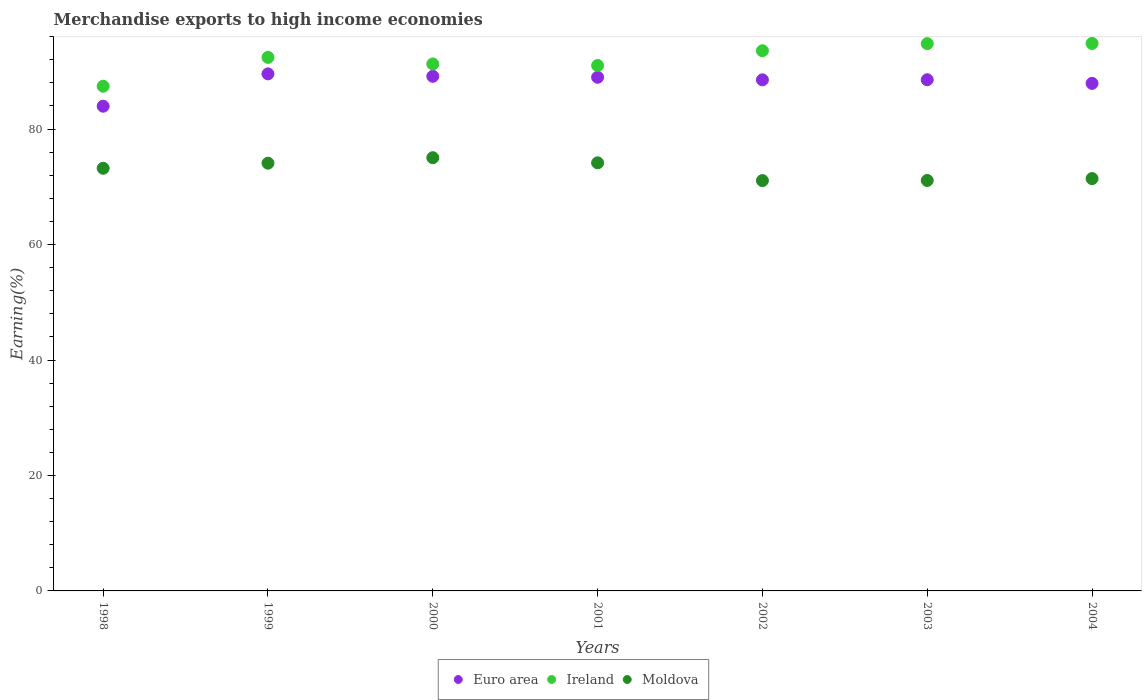How many different coloured dotlines are there?
Offer a terse response. 3. What is the percentage of amount earned from merchandise exports in Euro area in 1998?
Keep it short and to the point. 83.96. Across all years, what is the maximum percentage of amount earned from merchandise exports in Moldova?
Provide a short and direct response. 75.04. Across all years, what is the minimum percentage of amount earned from merchandise exports in Moldova?
Make the answer very short. 71.07. In which year was the percentage of amount earned from merchandise exports in Moldova maximum?
Provide a succinct answer. 2000. In which year was the percentage of amount earned from merchandise exports in Euro area minimum?
Your response must be concise. 1998. What is the total percentage of amount earned from merchandise exports in Ireland in the graph?
Your answer should be compact. 645.35. What is the difference between the percentage of amount earned from merchandise exports in Ireland in 2000 and that in 2002?
Your response must be concise. -2.29. What is the difference between the percentage of amount earned from merchandise exports in Euro area in 2003 and the percentage of amount earned from merchandise exports in Ireland in 2001?
Offer a very short reply. -2.47. What is the average percentage of amount earned from merchandise exports in Euro area per year?
Give a very brief answer. 88.09. In the year 2001, what is the difference between the percentage of amount earned from merchandise exports in Moldova and percentage of amount earned from merchandise exports in Ireland?
Keep it short and to the point. -16.86. In how many years, is the percentage of amount earned from merchandise exports in Moldova greater than 92 %?
Offer a very short reply. 0. What is the ratio of the percentage of amount earned from merchandise exports in Euro area in 2001 to that in 2002?
Offer a terse response. 1.01. Is the percentage of amount earned from merchandise exports in Ireland in 2000 less than that in 2004?
Give a very brief answer. Yes. What is the difference between the highest and the second highest percentage of amount earned from merchandise exports in Ireland?
Ensure brevity in your answer.  0.03. What is the difference between the highest and the lowest percentage of amount earned from merchandise exports in Euro area?
Provide a short and direct response. 5.6. In how many years, is the percentage of amount earned from merchandise exports in Moldova greater than the average percentage of amount earned from merchandise exports in Moldova taken over all years?
Offer a very short reply. 4. Is the sum of the percentage of amount earned from merchandise exports in Euro area in 1998 and 2002 greater than the maximum percentage of amount earned from merchandise exports in Ireland across all years?
Your answer should be compact. Yes. Is it the case that in every year, the sum of the percentage of amount earned from merchandise exports in Euro area and percentage of amount earned from merchandise exports in Ireland  is greater than the percentage of amount earned from merchandise exports in Moldova?
Your response must be concise. Yes. Does the percentage of amount earned from merchandise exports in Euro area monotonically increase over the years?
Your answer should be compact. No. Is the percentage of amount earned from merchandise exports in Euro area strictly less than the percentage of amount earned from merchandise exports in Moldova over the years?
Offer a terse response. No. How many dotlines are there?
Provide a short and direct response. 3. What is the difference between two consecutive major ticks on the Y-axis?
Provide a short and direct response. 20. Are the values on the major ticks of Y-axis written in scientific E-notation?
Give a very brief answer. No. Does the graph contain any zero values?
Provide a succinct answer. No. Does the graph contain grids?
Offer a terse response. No. Where does the legend appear in the graph?
Ensure brevity in your answer.  Bottom center. How many legend labels are there?
Make the answer very short. 3. What is the title of the graph?
Keep it short and to the point. Merchandise exports to high income economies. Does "Aruba" appear as one of the legend labels in the graph?
Give a very brief answer. No. What is the label or title of the Y-axis?
Make the answer very short. Earning(%). What is the Earning(%) of Euro area in 1998?
Ensure brevity in your answer.  83.96. What is the Earning(%) of Ireland in 1998?
Ensure brevity in your answer.  87.42. What is the Earning(%) in Moldova in 1998?
Keep it short and to the point. 73.21. What is the Earning(%) of Euro area in 1999?
Make the answer very short. 89.56. What is the Earning(%) in Ireland in 1999?
Give a very brief answer. 92.42. What is the Earning(%) in Moldova in 1999?
Ensure brevity in your answer.  74.09. What is the Earning(%) of Euro area in 2000?
Keep it short and to the point. 89.14. What is the Earning(%) in Ireland in 2000?
Keep it short and to the point. 91.28. What is the Earning(%) in Moldova in 2000?
Keep it short and to the point. 75.04. What is the Earning(%) of Euro area in 2001?
Make the answer very short. 88.98. What is the Earning(%) in Ireland in 2001?
Provide a short and direct response. 91.01. What is the Earning(%) of Moldova in 2001?
Your answer should be very brief. 74.15. What is the Earning(%) of Euro area in 2002?
Offer a very short reply. 88.53. What is the Earning(%) of Ireland in 2002?
Offer a very short reply. 93.57. What is the Earning(%) of Moldova in 2002?
Keep it short and to the point. 71.07. What is the Earning(%) in Euro area in 2003?
Make the answer very short. 88.55. What is the Earning(%) in Ireland in 2003?
Offer a terse response. 94.81. What is the Earning(%) of Moldova in 2003?
Provide a short and direct response. 71.1. What is the Earning(%) in Euro area in 2004?
Provide a short and direct response. 87.92. What is the Earning(%) in Ireland in 2004?
Keep it short and to the point. 94.84. What is the Earning(%) of Moldova in 2004?
Make the answer very short. 71.43. Across all years, what is the maximum Earning(%) in Euro area?
Give a very brief answer. 89.56. Across all years, what is the maximum Earning(%) of Ireland?
Make the answer very short. 94.84. Across all years, what is the maximum Earning(%) in Moldova?
Offer a terse response. 75.04. Across all years, what is the minimum Earning(%) of Euro area?
Ensure brevity in your answer.  83.96. Across all years, what is the minimum Earning(%) in Ireland?
Ensure brevity in your answer.  87.42. Across all years, what is the minimum Earning(%) of Moldova?
Offer a terse response. 71.07. What is the total Earning(%) of Euro area in the graph?
Provide a short and direct response. 616.64. What is the total Earning(%) of Ireland in the graph?
Your response must be concise. 645.35. What is the total Earning(%) in Moldova in the graph?
Keep it short and to the point. 510.1. What is the difference between the Earning(%) of Euro area in 1998 and that in 1999?
Your answer should be very brief. -5.6. What is the difference between the Earning(%) of Ireland in 1998 and that in 1999?
Offer a very short reply. -5. What is the difference between the Earning(%) of Moldova in 1998 and that in 1999?
Keep it short and to the point. -0.88. What is the difference between the Earning(%) of Euro area in 1998 and that in 2000?
Offer a terse response. -5.18. What is the difference between the Earning(%) in Ireland in 1998 and that in 2000?
Keep it short and to the point. -3.86. What is the difference between the Earning(%) in Moldova in 1998 and that in 2000?
Your answer should be compact. -1.83. What is the difference between the Earning(%) of Euro area in 1998 and that in 2001?
Provide a succinct answer. -5.01. What is the difference between the Earning(%) in Ireland in 1998 and that in 2001?
Ensure brevity in your answer.  -3.59. What is the difference between the Earning(%) of Moldova in 1998 and that in 2001?
Provide a succinct answer. -0.94. What is the difference between the Earning(%) in Euro area in 1998 and that in 2002?
Make the answer very short. -4.57. What is the difference between the Earning(%) in Ireland in 1998 and that in 2002?
Offer a terse response. -6.14. What is the difference between the Earning(%) in Moldova in 1998 and that in 2002?
Provide a succinct answer. 2.14. What is the difference between the Earning(%) in Euro area in 1998 and that in 2003?
Provide a succinct answer. -4.58. What is the difference between the Earning(%) in Ireland in 1998 and that in 2003?
Provide a succinct answer. -7.38. What is the difference between the Earning(%) in Moldova in 1998 and that in 2003?
Provide a succinct answer. 2.11. What is the difference between the Earning(%) of Euro area in 1998 and that in 2004?
Ensure brevity in your answer.  -3.96. What is the difference between the Earning(%) in Ireland in 1998 and that in 2004?
Provide a succinct answer. -7.41. What is the difference between the Earning(%) in Moldova in 1998 and that in 2004?
Give a very brief answer. 1.78. What is the difference between the Earning(%) of Euro area in 1999 and that in 2000?
Provide a short and direct response. 0.42. What is the difference between the Earning(%) in Ireland in 1999 and that in 2000?
Your answer should be very brief. 1.14. What is the difference between the Earning(%) in Moldova in 1999 and that in 2000?
Offer a very short reply. -0.95. What is the difference between the Earning(%) of Euro area in 1999 and that in 2001?
Keep it short and to the point. 0.59. What is the difference between the Earning(%) in Ireland in 1999 and that in 2001?
Offer a terse response. 1.41. What is the difference between the Earning(%) of Moldova in 1999 and that in 2001?
Make the answer very short. -0.06. What is the difference between the Earning(%) in Euro area in 1999 and that in 2002?
Offer a terse response. 1.03. What is the difference between the Earning(%) in Ireland in 1999 and that in 2002?
Provide a succinct answer. -1.15. What is the difference between the Earning(%) of Moldova in 1999 and that in 2002?
Make the answer very short. 3.02. What is the difference between the Earning(%) in Euro area in 1999 and that in 2003?
Your answer should be very brief. 1.02. What is the difference between the Earning(%) of Ireland in 1999 and that in 2003?
Provide a succinct answer. -2.39. What is the difference between the Earning(%) of Moldova in 1999 and that in 2003?
Your answer should be very brief. 2.99. What is the difference between the Earning(%) in Euro area in 1999 and that in 2004?
Make the answer very short. 1.64. What is the difference between the Earning(%) of Ireland in 1999 and that in 2004?
Make the answer very short. -2.42. What is the difference between the Earning(%) of Moldova in 1999 and that in 2004?
Offer a terse response. 2.67. What is the difference between the Earning(%) in Euro area in 2000 and that in 2001?
Offer a terse response. 0.17. What is the difference between the Earning(%) in Ireland in 2000 and that in 2001?
Ensure brevity in your answer.  0.27. What is the difference between the Earning(%) in Moldova in 2000 and that in 2001?
Offer a terse response. 0.89. What is the difference between the Earning(%) in Euro area in 2000 and that in 2002?
Give a very brief answer. 0.61. What is the difference between the Earning(%) in Ireland in 2000 and that in 2002?
Ensure brevity in your answer.  -2.29. What is the difference between the Earning(%) of Moldova in 2000 and that in 2002?
Your response must be concise. 3.97. What is the difference between the Earning(%) in Euro area in 2000 and that in 2003?
Provide a short and direct response. 0.59. What is the difference between the Earning(%) of Ireland in 2000 and that in 2003?
Your answer should be very brief. -3.53. What is the difference between the Earning(%) of Moldova in 2000 and that in 2003?
Give a very brief answer. 3.94. What is the difference between the Earning(%) in Euro area in 2000 and that in 2004?
Make the answer very short. 1.22. What is the difference between the Earning(%) of Ireland in 2000 and that in 2004?
Your answer should be very brief. -3.56. What is the difference between the Earning(%) of Moldova in 2000 and that in 2004?
Your response must be concise. 3.62. What is the difference between the Earning(%) in Euro area in 2001 and that in 2002?
Provide a short and direct response. 0.45. What is the difference between the Earning(%) of Ireland in 2001 and that in 2002?
Your answer should be very brief. -2.55. What is the difference between the Earning(%) in Moldova in 2001 and that in 2002?
Give a very brief answer. 3.08. What is the difference between the Earning(%) in Euro area in 2001 and that in 2003?
Your response must be concise. 0.43. What is the difference between the Earning(%) of Ireland in 2001 and that in 2003?
Offer a very short reply. -3.79. What is the difference between the Earning(%) of Moldova in 2001 and that in 2003?
Keep it short and to the point. 3.05. What is the difference between the Earning(%) in Euro area in 2001 and that in 2004?
Your answer should be very brief. 1.06. What is the difference between the Earning(%) of Ireland in 2001 and that in 2004?
Make the answer very short. -3.82. What is the difference between the Earning(%) of Moldova in 2001 and that in 2004?
Your response must be concise. 2.73. What is the difference between the Earning(%) of Euro area in 2002 and that in 2003?
Offer a terse response. -0.02. What is the difference between the Earning(%) in Ireland in 2002 and that in 2003?
Your answer should be very brief. -1.24. What is the difference between the Earning(%) in Moldova in 2002 and that in 2003?
Ensure brevity in your answer.  -0.03. What is the difference between the Earning(%) of Euro area in 2002 and that in 2004?
Give a very brief answer. 0.61. What is the difference between the Earning(%) in Ireland in 2002 and that in 2004?
Your response must be concise. -1.27. What is the difference between the Earning(%) of Moldova in 2002 and that in 2004?
Offer a terse response. -0.35. What is the difference between the Earning(%) of Euro area in 2003 and that in 2004?
Offer a terse response. 0.63. What is the difference between the Earning(%) in Ireland in 2003 and that in 2004?
Ensure brevity in your answer.  -0.03. What is the difference between the Earning(%) of Moldova in 2003 and that in 2004?
Give a very brief answer. -0.33. What is the difference between the Earning(%) of Euro area in 1998 and the Earning(%) of Ireland in 1999?
Make the answer very short. -8.46. What is the difference between the Earning(%) in Euro area in 1998 and the Earning(%) in Moldova in 1999?
Your response must be concise. 9.87. What is the difference between the Earning(%) in Ireland in 1998 and the Earning(%) in Moldova in 1999?
Offer a very short reply. 13.33. What is the difference between the Earning(%) in Euro area in 1998 and the Earning(%) in Ireland in 2000?
Ensure brevity in your answer.  -7.32. What is the difference between the Earning(%) of Euro area in 1998 and the Earning(%) of Moldova in 2000?
Your answer should be compact. 8.92. What is the difference between the Earning(%) in Ireland in 1998 and the Earning(%) in Moldova in 2000?
Keep it short and to the point. 12.38. What is the difference between the Earning(%) in Euro area in 1998 and the Earning(%) in Ireland in 2001?
Provide a short and direct response. -7.05. What is the difference between the Earning(%) of Euro area in 1998 and the Earning(%) of Moldova in 2001?
Keep it short and to the point. 9.81. What is the difference between the Earning(%) of Ireland in 1998 and the Earning(%) of Moldova in 2001?
Your answer should be compact. 13.27. What is the difference between the Earning(%) of Euro area in 1998 and the Earning(%) of Ireland in 2002?
Keep it short and to the point. -9.61. What is the difference between the Earning(%) of Euro area in 1998 and the Earning(%) of Moldova in 2002?
Your answer should be compact. 12.89. What is the difference between the Earning(%) of Ireland in 1998 and the Earning(%) of Moldova in 2002?
Offer a very short reply. 16.35. What is the difference between the Earning(%) of Euro area in 1998 and the Earning(%) of Ireland in 2003?
Keep it short and to the point. -10.84. What is the difference between the Earning(%) in Euro area in 1998 and the Earning(%) in Moldova in 2003?
Provide a short and direct response. 12.86. What is the difference between the Earning(%) in Ireland in 1998 and the Earning(%) in Moldova in 2003?
Make the answer very short. 16.32. What is the difference between the Earning(%) in Euro area in 1998 and the Earning(%) in Ireland in 2004?
Your answer should be compact. -10.87. What is the difference between the Earning(%) of Euro area in 1998 and the Earning(%) of Moldova in 2004?
Offer a terse response. 12.54. What is the difference between the Earning(%) of Ireland in 1998 and the Earning(%) of Moldova in 2004?
Ensure brevity in your answer.  16. What is the difference between the Earning(%) in Euro area in 1999 and the Earning(%) in Ireland in 2000?
Ensure brevity in your answer.  -1.72. What is the difference between the Earning(%) in Euro area in 1999 and the Earning(%) in Moldova in 2000?
Ensure brevity in your answer.  14.52. What is the difference between the Earning(%) of Ireland in 1999 and the Earning(%) of Moldova in 2000?
Your answer should be very brief. 17.38. What is the difference between the Earning(%) of Euro area in 1999 and the Earning(%) of Ireland in 2001?
Provide a succinct answer. -1.45. What is the difference between the Earning(%) of Euro area in 1999 and the Earning(%) of Moldova in 2001?
Provide a short and direct response. 15.41. What is the difference between the Earning(%) of Ireland in 1999 and the Earning(%) of Moldova in 2001?
Your response must be concise. 18.27. What is the difference between the Earning(%) in Euro area in 1999 and the Earning(%) in Ireland in 2002?
Give a very brief answer. -4. What is the difference between the Earning(%) in Euro area in 1999 and the Earning(%) in Moldova in 2002?
Ensure brevity in your answer.  18.49. What is the difference between the Earning(%) of Ireland in 1999 and the Earning(%) of Moldova in 2002?
Your response must be concise. 21.35. What is the difference between the Earning(%) of Euro area in 1999 and the Earning(%) of Ireland in 2003?
Your response must be concise. -5.24. What is the difference between the Earning(%) in Euro area in 1999 and the Earning(%) in Moldova in 2003?
Ensure brevity in your answer.  18.46. What is the difference between the Earning(%) of Ireland in 1999 and the Earning(%) of Moldova in 2003?
Provide a short and direct response. 21.32. What is the difference between the Earning(%) in Euro area in 1999 and the Earning(%) in Ireland in 2004?
Ensure brevity in your answer.  -5.27. What is the difference between the Earning(%) in Euro area in 1999 and the Earning(%) in Moldova in 2004?
Give a very brief answer. 18.14. What is the difference between the Earning(%) in Ireland in 1999 and the Earning(%) in Moldova in 2004?
Your answer should be very brief. 20.99. What is the difference between the Earning(%) of Euro area in 2000 and the Earning(%) of Ireland in 2001?
Give a very brief answer. -1.87. What is the difference between the Earning(%) in Euro area in 2000 and the Earning(%) in Moldova in 2001?
Your answer should be compact. 14.99. What is the difference between the Earning(%) of Ireland in 2000 and the Earning(%) of Moldova in 2001?
Provide a succinct answer. 17.13. What is the difference between the Earning(%) in Euro area in 2000 and the Earning(%) in Ireland in 2002?
Your answer should be compact. -4.43. What is the difference between the Earning(%) of Euro area in 2000 and the Earning(%) of Moldova in 2002?
Your response must be concise. 18.07. What is the difference between the Earning(%) of Ireland in 2000 and the Earning(%) of Moldova in 2002?
Offer a very short reply. 20.21. What is the difference between the Earning(%) in Euro area in 2000 and the Earning(%) in Ireland in 2003?
Keep it short and to the point. -5.67. What is the difference between the Earning(%) in Euro area in 2000 and the Earning(%) in Moldova in 2003?
Offer a terse response. 18.04. What is the difference between the Earning(%) of Ireland in 2000 and the Earning(%) of Moldova in 2003?
Give a very brief answer. 20.18. What is the difference between the Earning(%) in Euro area in 2000 and the Earning(%) in Ireland in 2004?
Your response must be concise. -5.7. What is the difference between the Earning(%) of Euro area in 2000 and the Earning(%) of Moldova in 2004?
Make the answer very short. 17.72. What is the difference between the Earning(%) in Ireland in 2000 and the Earning(%) in Moldova in 2004?
Provide a short and direct response. 19.85. What is the difference between the Earning(%) of Euro area in 2001 and the Earning(%) of Ireland in 2002?
Give a very brief answer. -4.59. What is the difference between the Earning(%) in Euro area in 2001 and the Earning(%) in Moldova in 2002?
Your response must be concise. 17.9. What is the difference between the Earning(%) in Ireland in 2001 and the Earning(%) in Moldova in 2002?
Offer a terse response. 19.94. What is the difference between the Earning(%) in Euro area in 2001 and the Earning(%) in Ireland in 2003?
Make the answer very short. -5.83. What is the difference between the Earning(%) of Euro area in 2001 and the Earning(%) of Moldova in 2003?
Ensure brevity in your answer.  17.88. What is the difference between the Earning(%) of Ireland in 2001 and the Earning(%) of Moldova in 2003?
Keep it short and to the point. 19.91. What is the difference between the Earning(%) of Euro area in 2001 and the Earning(%) of Ireland in 2004?
Your answer should be compact. -5.86. What is the difference between the Earning(%) of Euro area in 2001 and the Earning(%) of Moldova in 2004?
Give a very brief answer. 17.55. What is the difference between the Earning(%) in Ireland in 2001 and the Earning(%) in Moldova in 2004?
Your answer should be compact. 19.59. What is the difference between the Earning(%) in Euro area in 2002 and the Earning(%) in Ireland in 2003?
Your response must be concise. -6.28. What is the difference between the Earning(%) of Euro area in 2002 and the Earning(%) of Moldova in 2003?
Offer a terse response. 17.43. What is the difference between the Earning(%) of Ireland in 2002 and the Earning(%) of Moldova in 2003?
Your response must be concise. 22.47. What is the difference between the Earning(%) of Euro area in 2002 and the Earning(%) of Ireland in 2004?
Your response must be concise. -6.31. What is the difference between the Earning(%) in Euro area in 2002 and the Earning(%) in Moldova in 2004?
Your answer should be compact. 17.1. What is the difference between the Earning(%) in Ireland in 2002 and the Earning(%) in Moldova in 2004?
Provide a short and direct response. 22.14. What is the difference between the Earning(%) in Euro area in 2003 and the Earning(%) in Ireland in 2004?
Your response must be concise. -6.29. What is the difference between the Earning(%) of Euro area in 2003 and the Earning(%) of Moldova in 2004?
Your answer should be very brief. 17.12. What is the difference between the Earning(%) in Ireland in 2003 and the Earning(%) in Moldova in 2004?
Your answer should be compact. 23.38. What is the average Earning(%) of Euro area per year?
Provide a short and direct response. 88.09. What is the average Earning(%) of Ireland per year?
Ensure brevity in your answer.  92.19. What is the average Earning(%) of Moldova per year?
Provide a short and direct response. 72.87. In the year 1998, what is the difference between the Earning(%) of Euro area and Earning(%) of Ireland?
Make the answer very short. -3.46. In the year 1998, what is the difference between the Earning(%) in Euro area and Earning(%) in Moldova?
Your response must be concise. 10.75. In the year 1998, what is the difference between the Earning(%) in Ireland and Earning(%) in Moldova?
Ensure brevity in your answer.  14.21. In the year 1999, what is the difference between the Earning(%) of Euro area and Earning(%) of Ireland?
Ensure brevity in your answer.  -2.86. In the year 1999, what is the difference between the Earning(%) in Euro area and Earning(%) in Moldova?
Offer a very short reply. 15.47. In the year 1999, what is the difference between the Earning(%) in Ireland and Earning(%) in Moldova?
Give a very brief answer. 18.33. In the year 2000, what is the difference between the Earning(%) of Euro area and Earning(%) of Ireland?
Your response must be concise. -2.14. In the year 2000, what is the difference between the Earning(%) of Euro area and Earning(%) of Moldova?
Keep it short and to the point. 14.1. In the year 2000, what is the difference between the Earning(%) in Ireland and Earning(%) in Moldova?
Offer a very short reply. 16.24. In the year 2001, what is the difference between the Earning(%) in Euro area and Earning(%) in Ireland?
Your answer should be compact. -2.04. In the year 2001, what is the difference between the Earning(%) in Euro area and Earning(%) in Moldova?
Ensure brevity in your answer.  14.82. In the year 2001, what is the difference between the Earning(%) in Ireland and Earning(%) in Moldova?
Keep it short and to the point. 16.86. In the year 2002, what is the difference between the Earning(%) of Euro area and Earning(%) of Ireland?
Offer a very short reply. -5.04. In the year 2002, what is the difference between the Earning(%) in Euro area and Earning(%) in Moldova?
Ensure brevity in your answer.  17.45. In the year 2002, what is the difference between the Earning(%) of Ireland and Earning(%) of Moldova?
Make the answer very short. 22.49. In the year 2003, what is the difference between the Earning(%) of Euro area and Earning(%) of Ireland?
Provide a short and direct response. -6.26. In the year 2003, what is the difference between the Earning(%) of Euro area and Earning(%) of Moldova?
Keep it short and to the point. 17.45. In the year 2003, what is the difference between the Earning(%) of Ireland and Earning(%) of Moldova?
Give a very brief answer. 23.71. In the year 2004, what is the difference between the Earning(%) of Euro area and Earning(%) of Ireland?
Your answer should be very brief. -6.92. In the year 2004, what is the difference between the Earning(%) of Euro area and Earning(%) of Moldova?
Provide a short and direct response. 16.49. In the year 2004, what is the difference between the Earning(%) of Ireland and Earning(%) of Moldova?
Offer a very short reply. 23.41. What is the ratio of the Earning(%) of Euro area in 1998 to that in 1999?
Ensure brevity in your answer.  0.94. What is the ratio of the Earning(%) in Ireland in 1998 to that in 1999?
Make the answer very short. 0.95. What is the ratio of the Earning(%) in Moldova in 1998 to that in 1999?
Offer a very short reply. 0.99. What is the ratio of the Earning(%) of Euro area in 1998 to that in 2000?
Offer a very short reply. 0.94. What is the ratio of the Earning(%) in Ireland in 1998 to that in 2000?
Your answer should be compact. 0.96. What is the ratio of the Earning(%) of Moldova in 1998 to that in 2000?
Keep it short and to the point. 0.98. What is the ratio of the Earning(%) in Euro area in 1998 to that in 2001?
Ensure brevity in your answer.  0.94. What is the ratio of the Earning(%) in Ireland in 1998 to that in 2001?
Offer a very short reply. 0.96. What is the ratio of the Earning(%) in Moldova in 1998 to that in 2001?
Provide a succinct answer. 0.99. What is the ratio of the Earning(%) of Euro area in 1998 to that in 2002?
Offer a terse response. 0.95. What is the ratio of the Earning(%) in Ireland in 1998 to that in 2002?
Your answer should be very brief. 0.93. What is the ratio of the Earning(%) of Moldova in 1998 to that in 2002?
Your response must be concise. 1.03. What is the ratio of the Earning(%) in Euro area in 1998 to that in 2003?
Keep it short and to the point. 0.95. What is the ratio of the Earning(%) of Ireland in 1998 to that in 2003?
Ensure brevity in your answer.  0.92. What is the ratio of the Earning(%) in Moldova in 1998 to that in 2003?
Offer a terse response. 1.03. What is the ratio of the Earning(%) in Euro area in 1998 to that in 2004?
Provide a succinct answer. 0.95. What is the ratio of the Earning(%) of Ireland in 1998 to that in 2004?
Keep it short and to the point. 0.92. What is the ratio of the Earning(%) in Moldova in 1998 to that in 2004?
Offer a terse response. 1.02. What is the ratio of the Earning(%) in Ireland in 1999 to that in 2000?
Provide a short and direct response. 1.01. What is the ratio of the Earning(%) in Moldova in 1999 to that in 2000?
Make the answer very short. 0.99. What is the ratio of the Earning(%) in Euro area in 1999 to that in 2001?
Give a very brief answer. 1.01. What is the ratio of the Earning(%) in Ireland in 1999 to that in 2001?
Offer a very short reply. 1.02. What is the ratio of the Earning(%) of Moldova in 1999 to that in 2001?
Make the answer very short. 1. What is the ratio of the Earning(%) of Euro area in 1999 to that in 2002?
Provide a succinct answer. 1.01. What is the ratio of the Earning(%) in Moldova in 1999 to that in 2002?
Offer a very short reply. 1.04. What is the ratio of the Earning(%) of Euro area in 1999 to that in 2003?
Offer a very short reply. 1.01. What is the ratio of the Earning(%) in Ireland in 1999 to that in 2003?
Provide a short and direct response. 0.97. What is the ratio of the Earning(%) of Moldova in 1999 to that in 2003?
Offer a terse response. 1.04. What is the ratio of the Earning(%) in Euro area in 1999 to that in 2004?
Your answer should be compact. 1.02. What is the ratio of the Earning(%) of Ireland in 1999 to that in 2004?
Provide a succinct answer. 0.97. What is the ratio of the Earning(%) of Moldova in 1999 to that in 2004?
Provide a succinct answer. 1.04. What is the ratio of the Earning(%) of Euro area in 2000 to that in 2001?
Your response must be concise. 1. What is the ratio of the Earning(%) in Ireland in 2000 to that in 2002?
Ensure brevity in your answer.  0.98. What is the ratio of the Earning(%) in Moldova in 2000 to that in 2002?
Offer a terse response. 1.06. What is the ratio of the Earning(%) of Ireland in 2000 to that in 2003?
Your response must be concise. 0.96. What is the ratio of the Earning(%) in Moldova in 2000 to that in 2003?
Ensure brevity in your answer.  1.06. What is the ratio of the Earning(%) in Euro area in 2000 to that in 2004?
Offer a terse response. 1.01. What is the ratio of the Earning(%) of Ireland in 2000 to that in 2004?
Offer a terse response. 0.96. What is the ratio of the Earning(%) in Moldova in 2000 to that in 2004?
Offer a terse response. 1.05. What is the ratio of the Earning(%) in Euro area in 2001 to that in 2002?
Keep it short and to the point. 1.01. What is the ratio of the Earning(%) in Ireland in 2001 to that in 2002?
Offer a very short reply. 0.97. What is the ratio of the Earning(%) of Moldova in 2001 to that in 2002?
Offer a terse response. 1.04. What is the ratio of the Earning(%) in Euro area in 2001 to that in 2003?
Keep it short and to the point. 1. What is the ratio of the Earning(%) of Moldova in 2001 to that in 2003?
Offer a very short reply. 1.04. What is the ratio of the Earning(%) of Ireland in 2001 to that in 2004?
Keep it short and to the point. 0.96. What is the ratio of the Earning(%) of Moldova in 2001 to that in 2004?
Offer a terse response. 1.04. What is the ratio of the Earning(%) in Ireland in 2002 to that in 2003?
Offer a very short reply. 0.99. What is the ratio of the Earning(%) of Moldova in 2002 to that in 2003?
Your answer should be compact. 1. What is the ratio of the Earning(%) in Ireland in 2002 to that in 2004?
Provide a succinct answer. 0.99. What is the ratio of the Earning(%) in Euro area in 2003 to that in 2004?
Offer a very short reply. 1.01. What is the ratio of the Earning(%) in Ireland in 2003 to that in 2004?
Give a very brief answer. 1. What is the difference between the highest and the second highest Earning(%) of Euro area?
Ensure brevity in your answer.  0.42. What is the difference between the highest and the second highest Earning(%) of Ireland?
Give a very brief answer. 0.03. What is the difference between the highest and the second highest Earning(%) of Moldova?
Your answer should be compact. 0.89. What is the difference between the highest and the lowest Earning(%) of Euro area?
Offer a terse response. 5.6. What is the difference between the highest and the lowest Earning(%) in Ireland?
Provide a succinct answer. 7.41. What is the difference between the highest and the lowest Earning(%) of Moldova?
Offer a terse response. 3.97. 